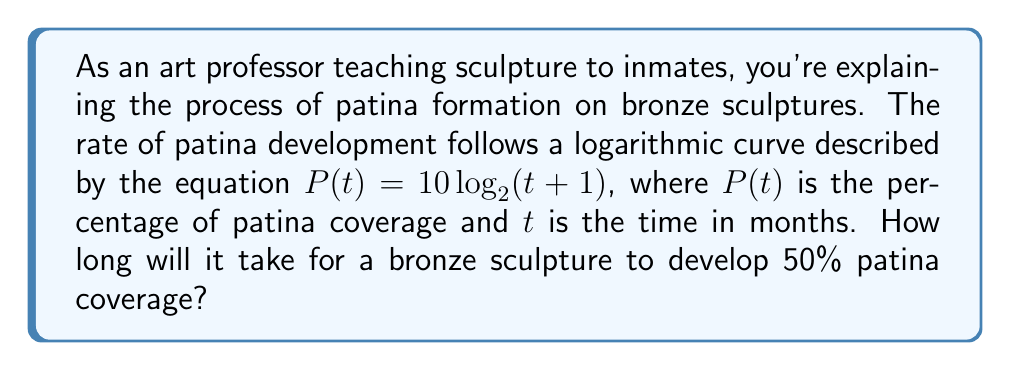Show me your answer to this math problem. To solve this problem, we need to use the given logarithmic equation and solve for $t$ when $P(t) = 50$.

1. Start with the equation: $P(t) = 10 \log_{2}(t+1)$

2. Substitute $P(t)$ with 50:
   $50 = 10 \log_{2}(t+1)$

3. Divide both sides by 10:
   $5 = \log_{2}(t+1)$

4. To isolate $t$, we need to apply the inverse function (exponential) to both sides:
   $2^5 = t+1$

5. Simplify the left side:
   $32 = t+1$

6. Subtract 1 from both sides:
   $31 = t$

Therefore, it will take 31 months for the bronze sculpture to develop 50% patina coverage.
Answer: 31 months 